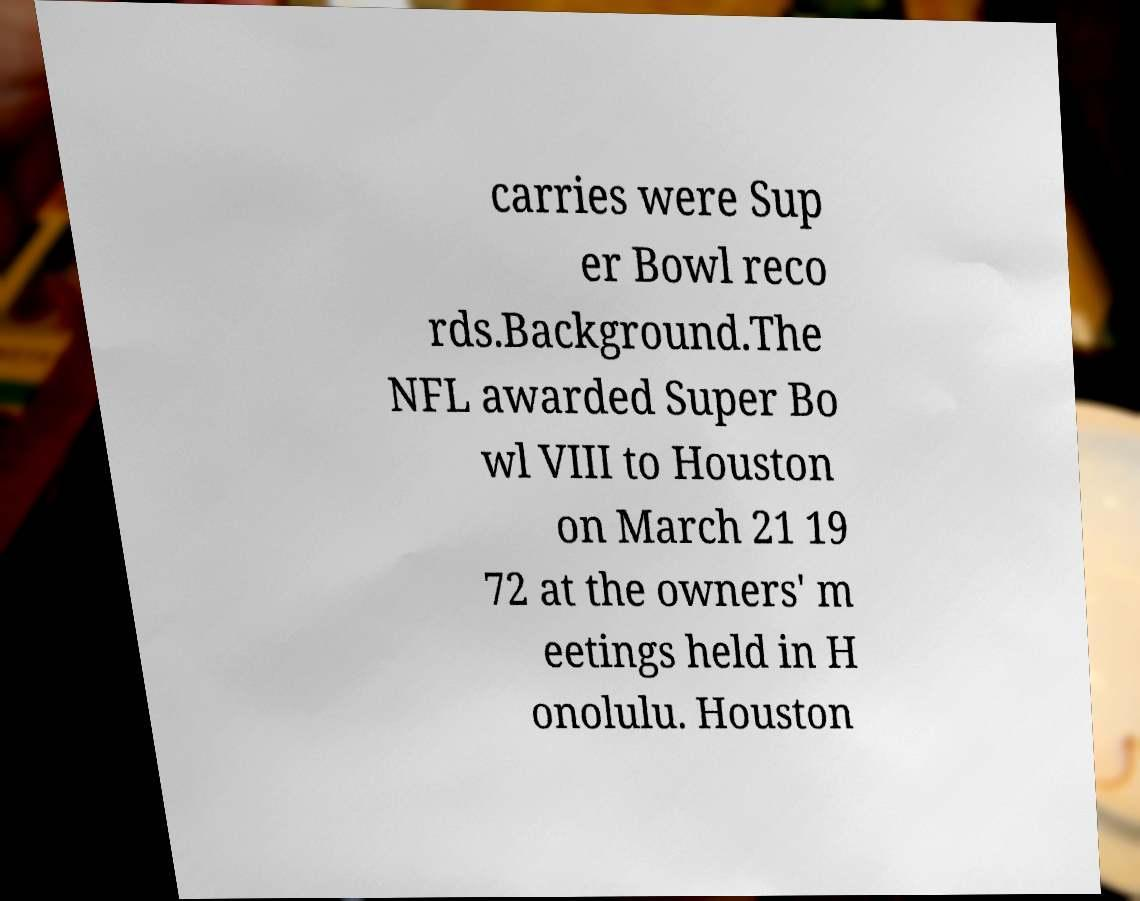Please read and relay the text visible in this image. What does it say? carries were Sup er Bowl reco rds.Background.The NFL awarded Super Bo wl VIII to Houston on March 21 19 72 at the owners' m eetings held in H onolulu. Houston 